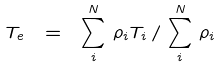Convert formula to latex. <formula><loc_0><loc_0><loc_500><loc_500>T _ { e } \ = \ \sum _ { i } ^ { N } \, \rho _ { i } T _ { i } \, / \, \sum _ { i } ^ { N } \, \rho _ { i }</formula> 